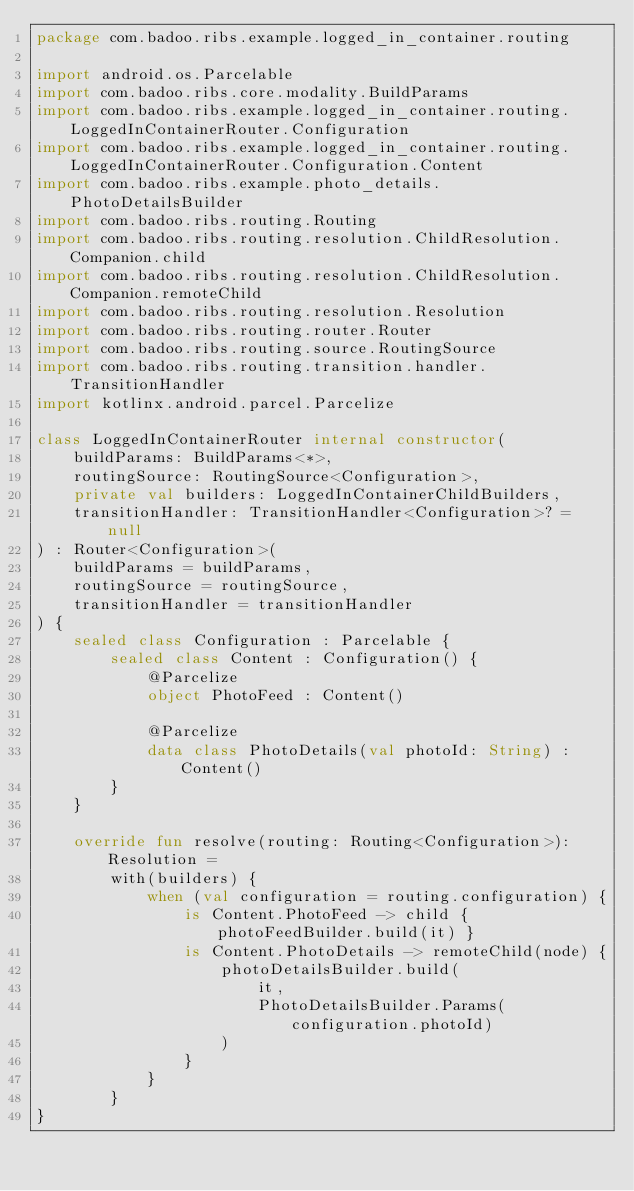Convert code to text. <code><loc_0><loc_0><loc_500><loc_500><_Kotlin_>package com.badoo.ribs.example.logged_in_container.routing

import android.os.Parcelable
import com.badoo.ribs.core.modality.BuildParams
import com.badoo.ribs.example.logged_in_container.routing.LoggedInContainerRouter.Configuration
import com.badoo.ribs.example.logged_in_container.routing.LoggedInContainerRouter.Configuration.Content
import com.badoo.ribs.example.photo_details.PhotoDetailsBuilder
import com.badoo.ribs.routing.Routing
import com.badoo.ribs.routing.resolution.ChildResolution.Companion.child
import com.badoo.ribs.routing.resolution.ChildResolution.Companion.remoteChild
import com.badoo.ribs.routing.resolution.Resolution
import com.badoo.ribs.routing.router.Router
import com.badoo.ribs.routing.source.RoutingSource
import com.badoo.ribs.routing.transition.handler.TransitionHandler
import kotlinx.android.parcel.Parcelize

class LoggedInContainerRouter internal constructor(
    buildParams: BuildParams<*>,
    routingSource: RoutingSource<Configuration>,
    private val builders: LoggedInContainerChildBuilders,
    transitionHandler: TransitionHandler<Configuration>? = null
) : Router<Configuration>(
    buildParams = buildParams,
    routingSource = routingSource,
    transitionHandler = transitionHandler
) {
    sealed class Configuration : Parcelable {
        sealed class Content : Configuration() {
            @Parcelize
            object PhotoFeed : Content()

            @Parcelize
            data class PhotoDetails(val photoId: String) : Content()
        }
    }

    override fun resolve(routing: Routing<Configuration>): Resolution =
        with(builders) {
            when (val configuration = routing.configuration) {
                is Content.PhotoFeed -> child { photoFeedBuilder.build(it) }
                is Content.PhotoDetails -> remoteChild(node) {
                    photoDetailsBuilder.build(
                        it,
                        PhotoDetailsBuilder.Params(configuration.photoId)
                    )
                }
            }
        }
}

</code> 